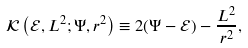Convert formula to latex. <formula><loc_0><loc_0><loc_500><loc_500>\mathcal { K } \left ( \mathcal { E } , L ^ { 2 } ; \Psi , r ^ { 2 } \right ) \equiv 2 ( \Psi - \mathcal { E } ) - \frac { L ^ { 2 } } { r ^ { 2 } } ,</formula> 